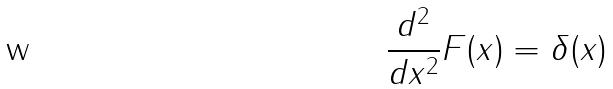Convert formula to latex. <formula><loc_0><loc_0><loc_500><loc_500>\frac { d ^ { 2 } } { d x ^ { 2 } } F ( x ) = \delta ( x )</formula> 